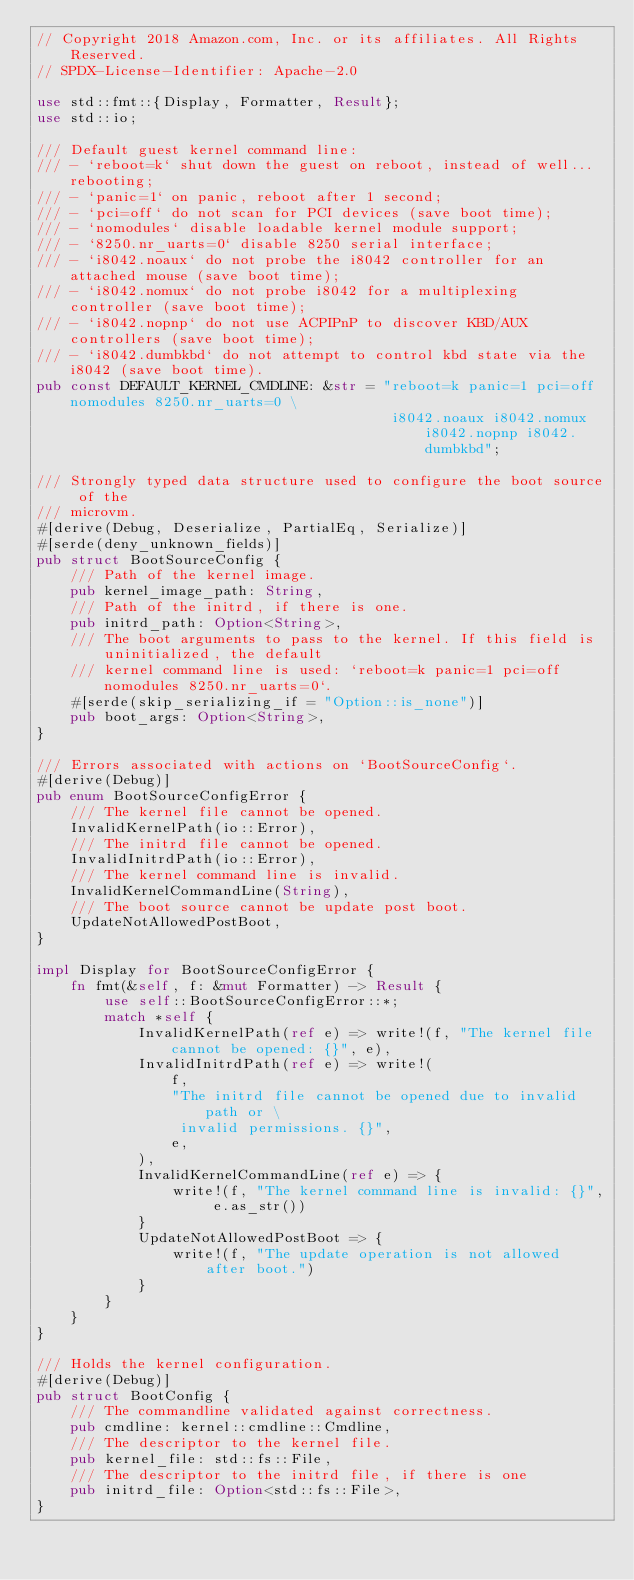Convert code to text. <code><loc_0><loc_0><loc_500><loc_500><_Rust_>// Copyright 2018 Amazon.com, Inc. or its affiliates. All Rights Reserved.
// SPDX-License-Identifier: Apache-2.0

use std::fmt::{Display, Formatter, Result};
use std::io;

/// Default guest kernel command line:
/// - `reboot=k` shut down the guest on reboot, instead of well... rebooting;
/// - `panic=1` on panic, reboot after 1 second;
/// - `pci=off` do not scan for PCI devices (save boot time);
/// - `nomodules` disable loadable kernel module support;
/// - `8250.nr_uarts=0` disable 8250 serial interface;
/// - `i8042.noaux` do not probe the i8042 controller for an attached mouse (save boot time);
/// - `i8042.nomux` do not probe i8042 for a multiplexing controller (save boot time);
/// - `i8042.nopnp` do not use ACPIPnP to discover KBD/AUX controllers (save boot time);
/// - `i8042.dumbkbd` do not attempt to control kbd state via the i8042 (save boot time).
pub const DEFAULT_KERNEL_CMDLINE: &str = "reboot=k panic=1 pci=off nomodules 8250.nr_uarts=0 \
                                          i8042.noaux i8042.nomux i8042.nopnp i8042.dumbkbd";

/// Strongly typed data structure used to configure the boot source of the
/// microvm.
#[derive(Debug, Deserialize, PartialEq, Serialize)]
#[serde(deny_unknown_fields)]
pub struct BootSourceConfig {
    /// Path of the kernel image.
    pub kernel_image_path: String,
    /// Path of the initrd, if there is one.
    pub initrd_path: Option<String>,
    /// The boot arguments to pass to the kernel. If this field is uninitialized, the default
    /// kernel command line is used: `reboot=k panic=1 pci=off nomodules 8250.nr_uarts=0`.
    #[serde(skip_serializing_if = "Option::is_none")]
    pub boot_args: Option<String>,
}

/// Errors associated with actions on `BootSourceConfig`.
#[derive(Debug)]
pub enum BootSourceConfigError {
    /// The kernel file cannot be opened.
    InvalidKernelPath(io::Error),
    /// The initrd file cannot be opened.
    InvalidInitrdPath(io::Error),
    /// The kernel command line is invalid.
    InvalidKernelCommandLine(String),
    /// The boot source cannot be update post boot.
    UpdateNotAllowedPostBoot,
}

impl Display for BootSourceConfigError {
    fn fmt(&self, f: &mut Formatter) -> Result {
        use self::BootSourceConfigError::*;
        match *self {
            InvalidKernelPath(ref e) => write!(f, "The kernel file cannot be opened: {}", e),
            InvalidInitrdPath(ref e) => write!(
                f,
                "The initrd file cannot be opened due to invalid path or \
                 invalid permissions. {}",
                e,
            ),
            InvalidKernelCommandLine(ref e) => {
                write!(f, "The kernel command line is invalid: {}", e.as_str())
            }
            UpdateNotAllowedPostBoot => {
                write!(f, "The update operation is not allowed after boot.")
            }
        }
    }
}

/// Holds the kernel configuration.
#[derive(Debug)]
pub struct BootConfig {
    /// The commandline validated against correctness.
    pub cmdline: kernel::cmdline::Cmdline,
    /// The descriptor to the kernel file.
    pub kernel_file: std::fs::File,
    /// The descriptor to the initrd file, if there is one
    pub initrd_file: Option<std::fs::File>,
}
</code> 